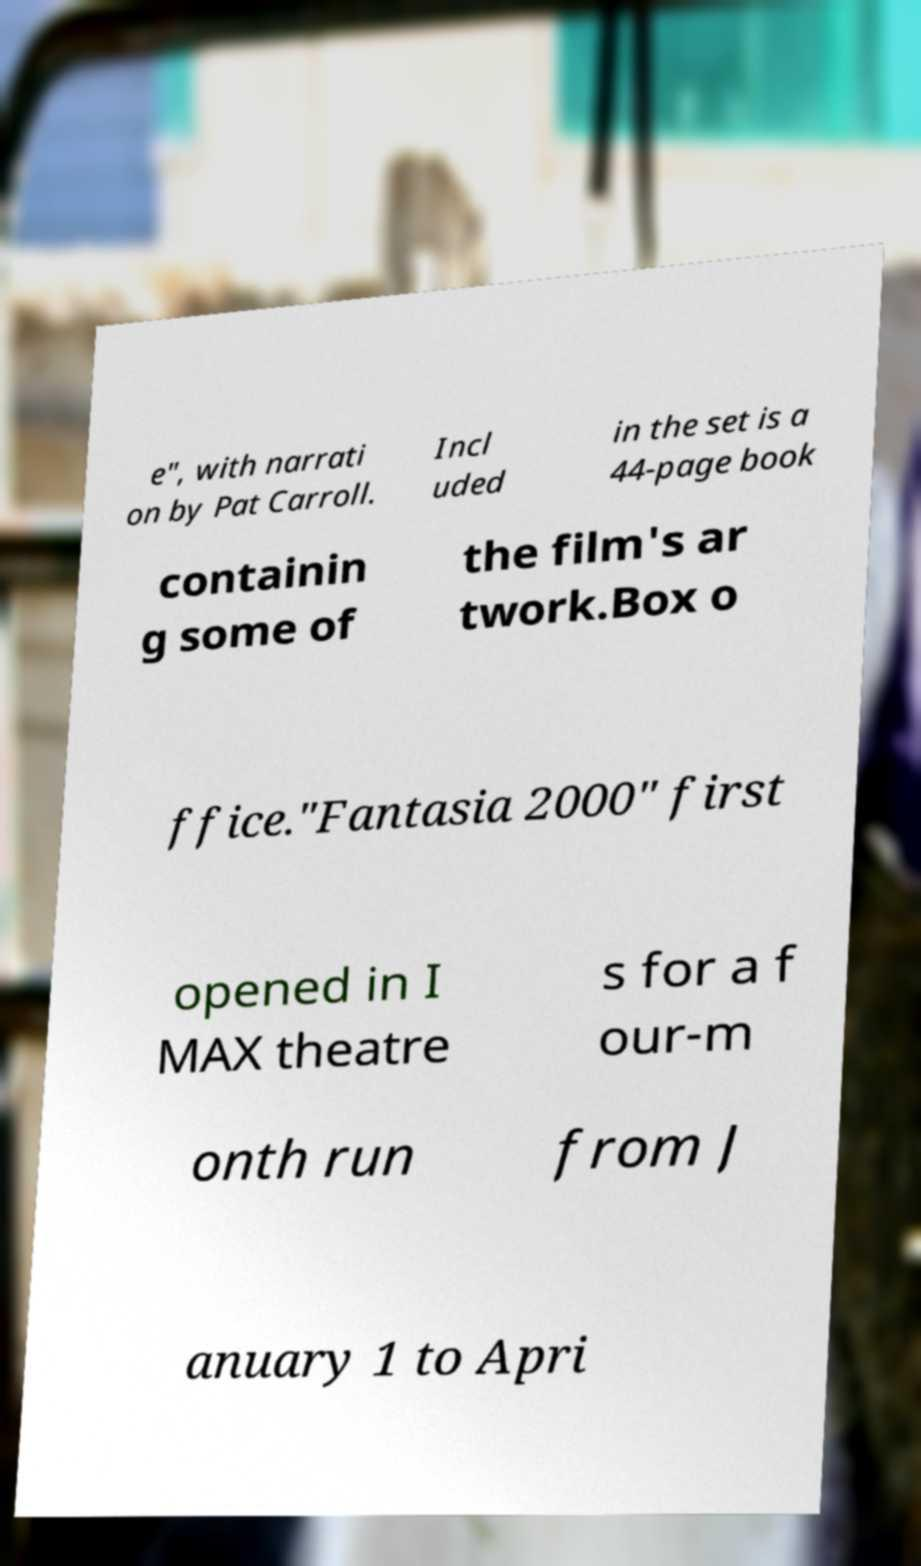Please read and relay the text visible in this image. What does it say? e", with narrati on by Pat Carroll. Incl uded in the set is a 44-page book containin g some of the film's ar twork.Box o ffice."Fantasia 2000" first opened in I MAX theatre s for a f our-m onth run from J anuary 1 to Apri 